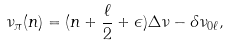<formula> <loc_0><loc_0><loc_500><loc_500>\nu _ { \pi } ( n ) = ( n + \frac { \ell } { 2 } + \epsilon ) \Delta \nu - \delta \nu _ { 0 \ell } ,</formula> 